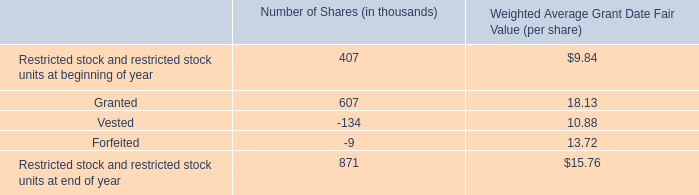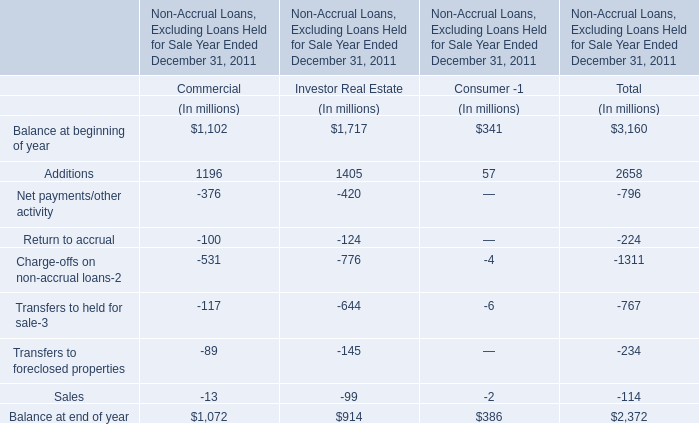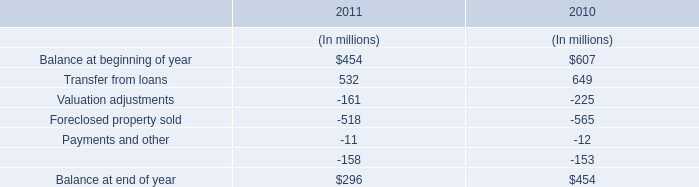What is the sum of Additions, Net payments/other activity and Net payments/other activity for Investor Real Estate ? (in million) 
Computations: ((1405 - 420) - 124)
Answer: 861.0. 